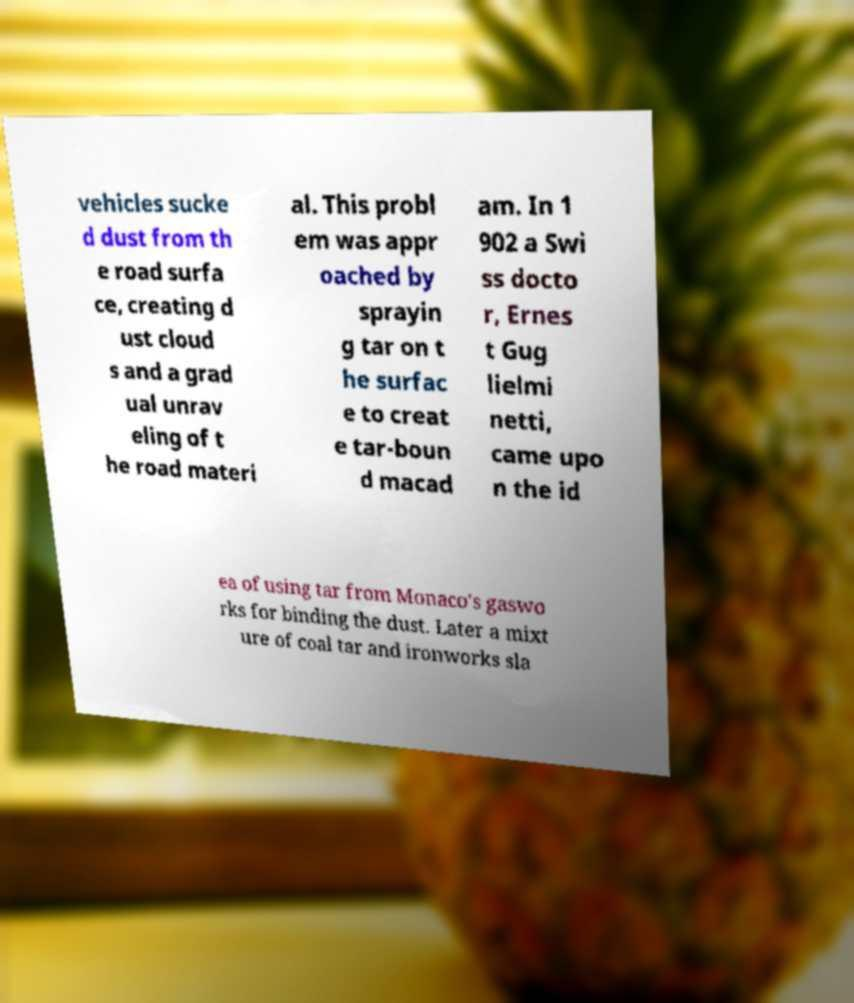Please read and relay the text visible in this image. What does it say? vehicles sucke d dust from th e road surfa ce, creating d ust cloud s and a grad ual unrav eling of t he road materi al. This probl em was appr oached by sprayin g tar on t he surfac e to creat e tar-boun d macad am. In 1 902 a Swi ss docto r, Ernes t Gug lielmi netti, came upo n the id ea of using tar from Monaco's gaswo rks for binding the dust. Later a mixt ure of coal tar and ironworks sla 